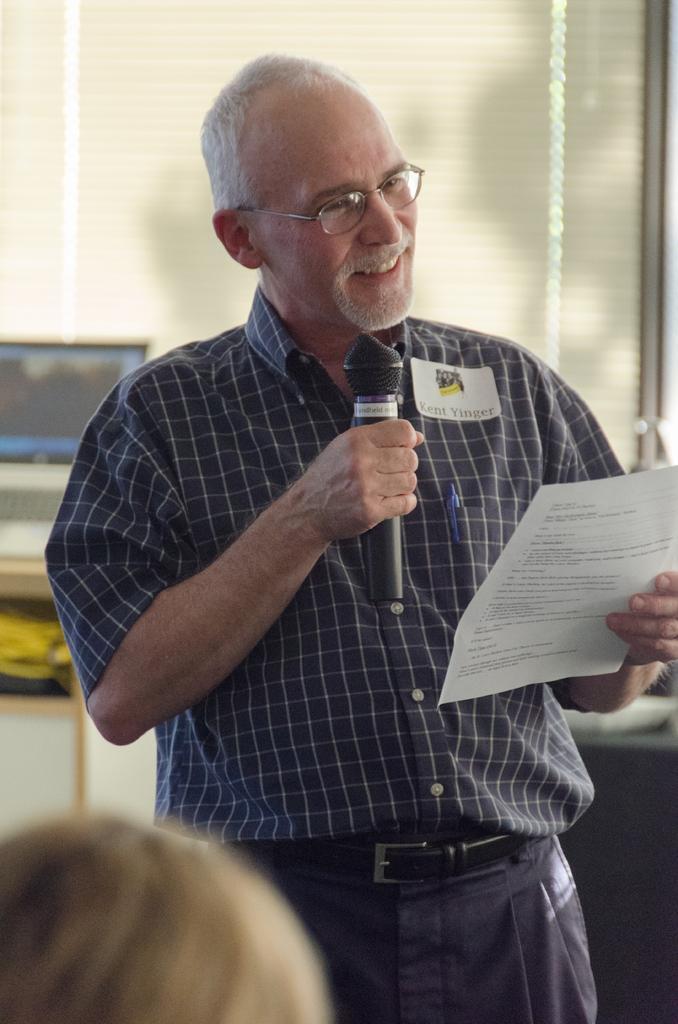Describe this image in one or two sentences. In this image, we can see a old human is holding a microphone and paper. On his shirt, there is a pen and sticker on it. He is smiling. He wear a glasses. At the bottom, we can see a human head. And back side, we can see ash color cupboard and white and cream color cupboard on right side. and here we can see a laptop,here there is a glass window and shade. 